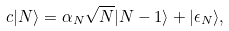Convert formula to latex. <formula><loc_0><loc_0><loc_500><loc_500>c | N \rangle = \alpha _ { N } \sqrt { N } | N - 1 \rangle + | \epsilon _ { N } \rangle ,</formula> 